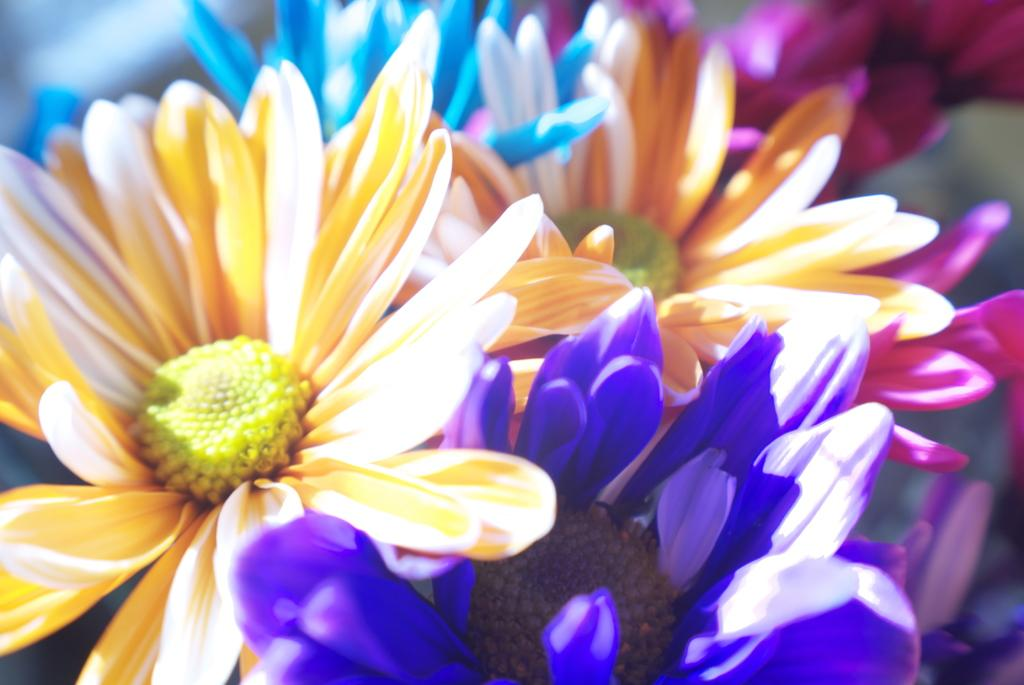What type of objects are present in the image? There are flowers in the image. Can you describe the flowers in the image? The flowers have different colors. What can be observed about the background of the image? The background of the image is blurry. What type of lunch is being prepared in the image? There is no indication of lunch or any food preparation in the image; it features flowers with different colors and a blurry background. 